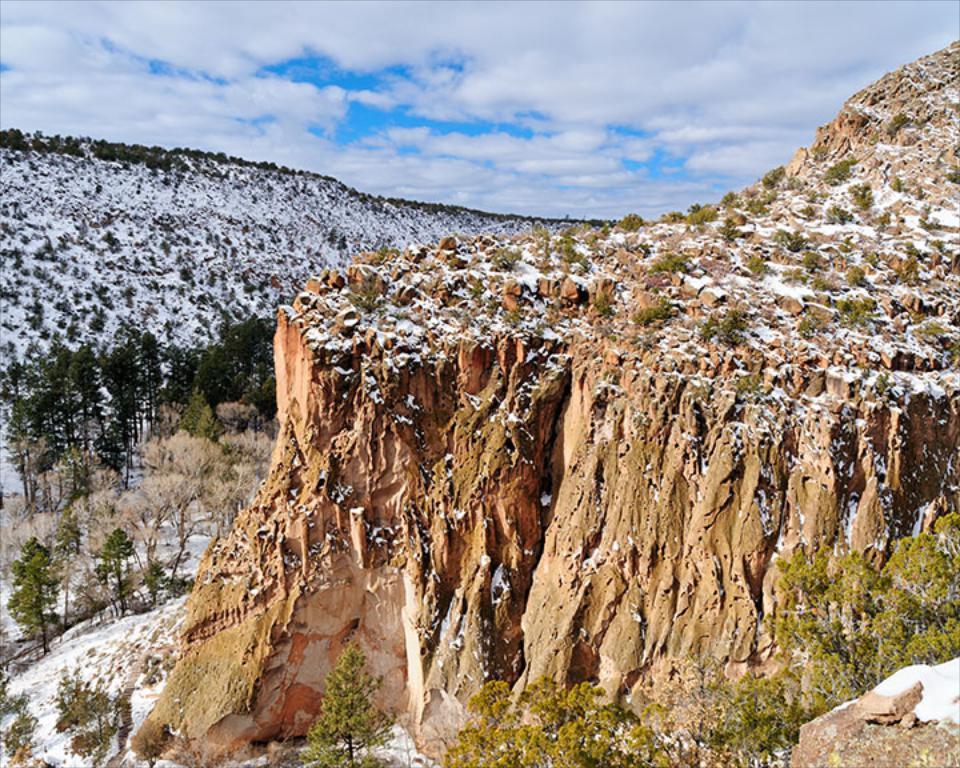Describe this image in one or two sentences. This image is taken outdoors. At the top of the image there is a sky with clouds. At the bottom of the image there are a few plants and trees. On the right side of the image there is a rock covered snow. In the background there are a few hills covered with snow. There are many trees and plants on the ground. 